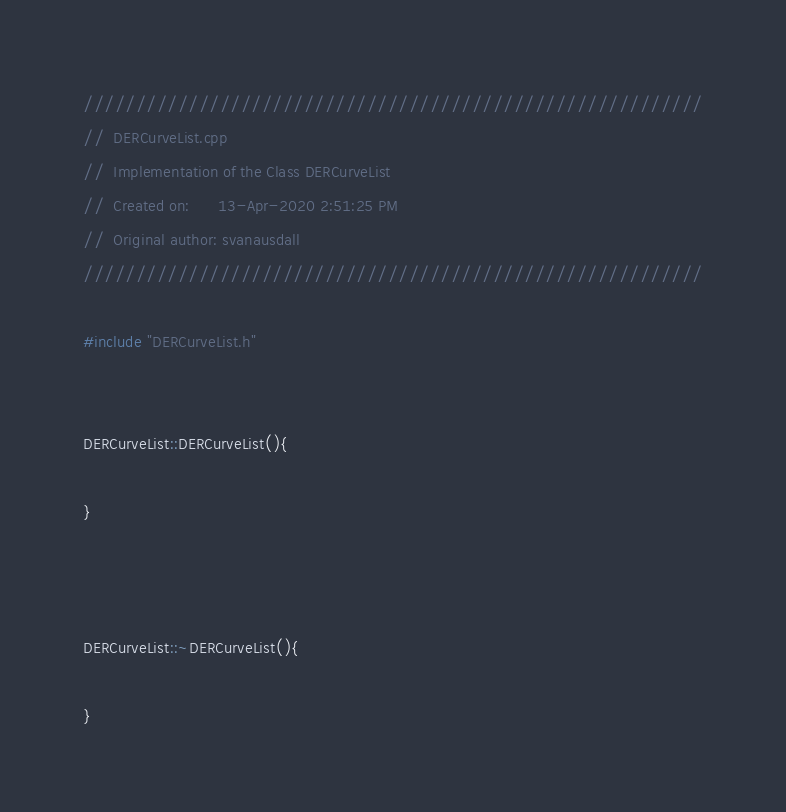Convert code to text. <code><loc_0><loc_0><loc_500><loc_500><_C++_>///////////////////////////////////////////////////////////
//  DERCurveList.cpp
//  Implementation of the Class DERCurveList
//  Created on:      13-Apr-2020 2:51:25 PM
//  Original author: svanausdall
///////////////////////////////////////////////////////////

#include "DERCurveList.h"


DERCurveList::DERCurveList(){

}



DERCurveList::~DERCurveList(){

}</code> 